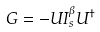Convert formula to latex. <formula><loc_0><loc_0><loc_500><loc_500>G = - U I _ { s } ^ { \beta } U ^ { \dagger }</formula> 